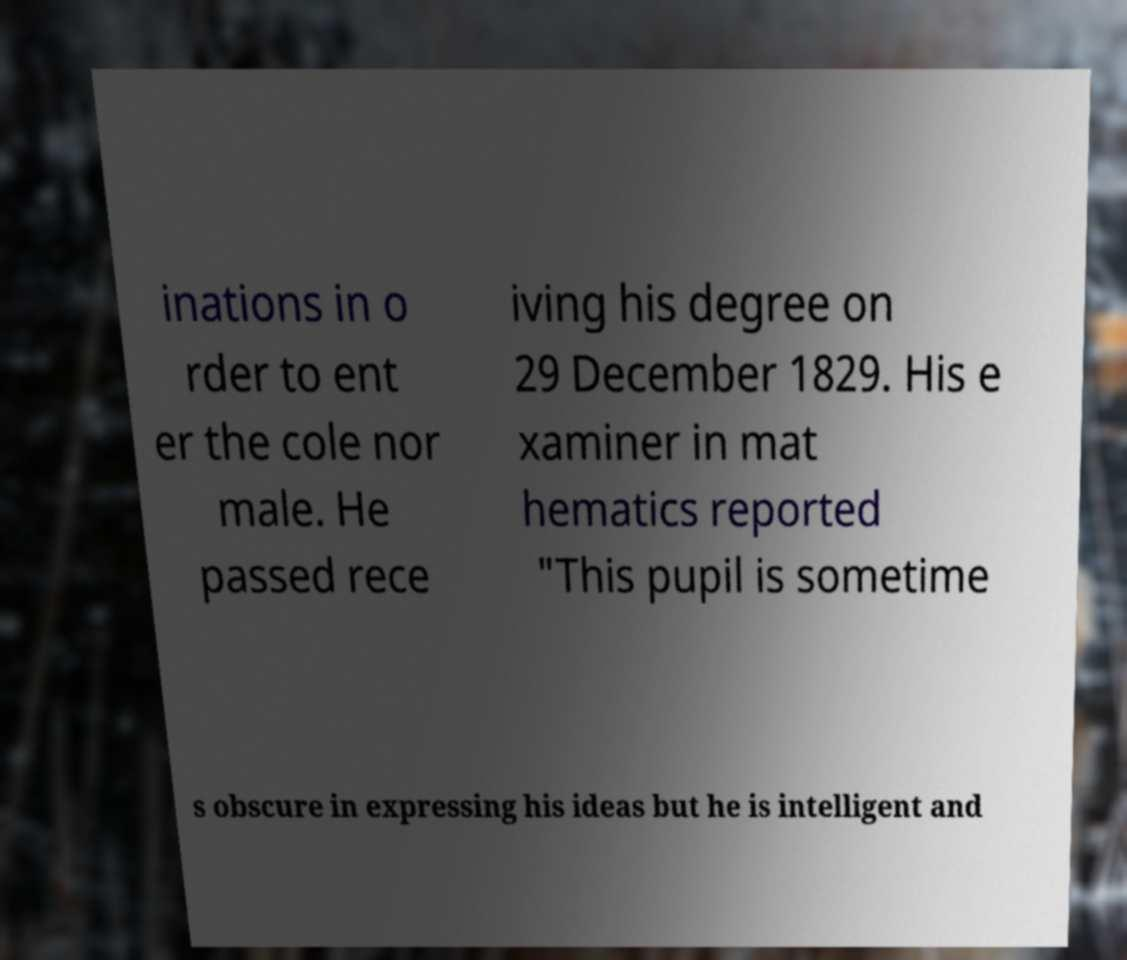Please read and relay the text visible in this image. What does it say? inations in o rder to ent er the cole nor male. He passed rece iving his degree on 29 December 1829. His e xaminer in mat hematics reported "This pupil is sometime s obscure in expressing his ideas but he is intelligent and 